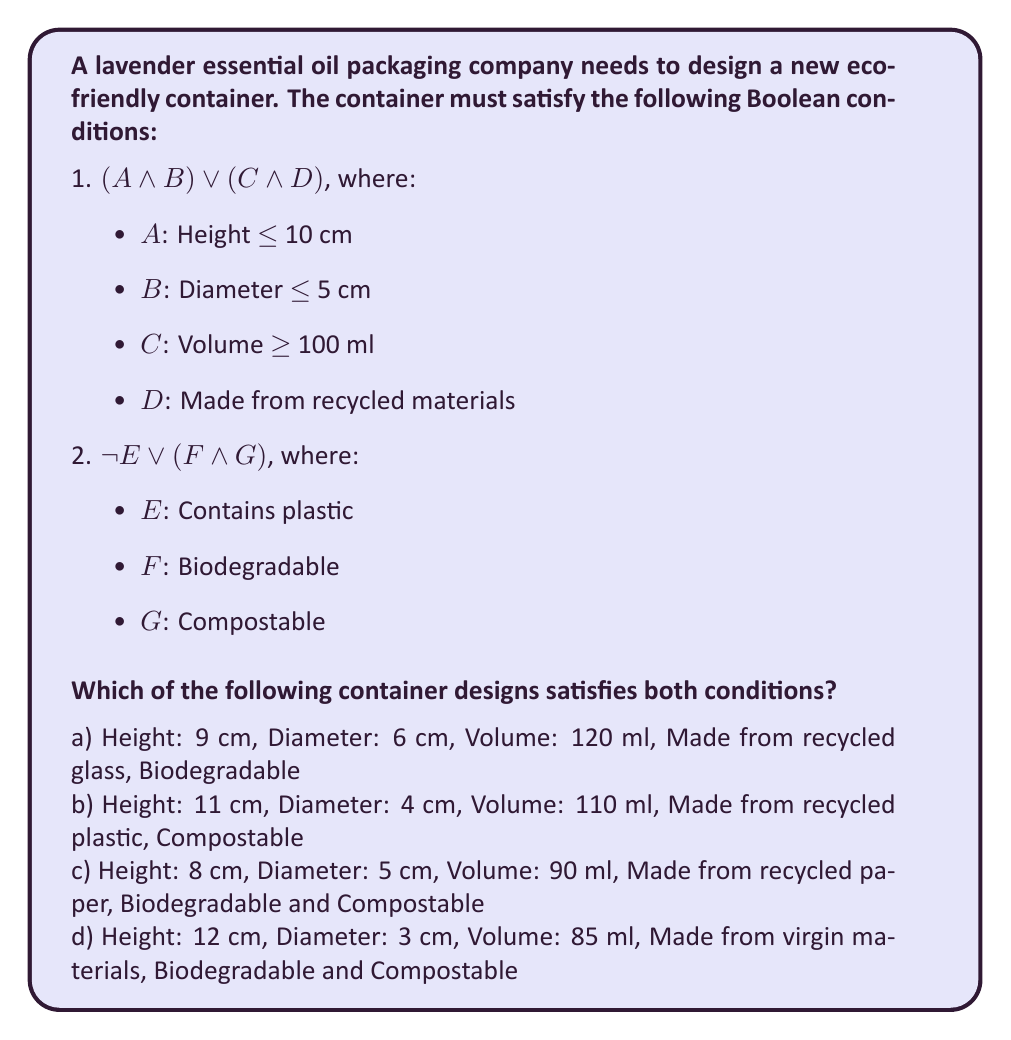Show me your answer to this math problem. Let's evaluate each option step-by-step using the given Boolean conditions:

1. Condition 1: $(A \land B) \lor (C \land D)$

2. Condition 2: $\lnot E \lor (F \land G)$

Option a:
- $A$ is true (9 cm $\leq$ 10 cm)
- $B$ is false (6 cm $\not\leq$ 5 cm)
- $C$ is true (120 ml $\geq$ 100 ml)
- $D$ is true (made from recycled glass)
- $E$ is false (glass, not plastic)
- $F$ is true (biodegradable)
- $G$ is false (not stated as compostable)

Condition 1: $(T \land F) \lor (T \land T) = F \lor T = T$
Condition 2: $\lnot F \lor (T \land F) = T \lor F = T$
Both conditions are satisfied.

Option b:
- $A$ is false (11 cm $\not\leq$ 10 cm)
- $B$ is true (4 cm $\leq$ 5 cm)
- $C$ is true (110 ml $\geq$ 100 ml)
- $D$ is true (made from recycled plastic)
- $E$ is true (contains plastic)
- $F$ is false (not stated as biodegradable)
- $G$ is true (compostable)

Condition 1: $(F \land T) \lor (T \land T) = F \lor T = T$
Condition 2: $\lnot T \lor (F \land T) = F \lor F = F$
Condition 2 is not satisfied.

Option c:
- $A$ is true (8 cm $\leq$ 10 cm)
- $B$ is true (5 cm $\leq$ 5 cm)
- $C$ is false (90 ml $\not\geq$ 100 ml)
- $D$ is true (made from recycled paper)
- $E$ is false (paper, not plastic)
- $F$ is true (biodegradable)
- $G$ is true (compostable)

Condition 1: $(T \land T) \lor (F \land T) = T \lor F = T$
Condition 2: $\lnot F \lor (T \land T) = T \lor T = T$
Both conditions are satisfied.

Option d:
- $A$ is false (12 cm $\not\leq$ 10 cm)
- $B$ is true (3 cm $\leq$ 5 cm)
- $C$ is false (85 ml $\not\geq$ 100 ml)
- $D$ is false (made from virgin materials)
- $E$ is false (not plastic)
- $F$ is true (biodegradable)
- $G$ is true (compostable)

Condition 1: $(F \land T) \lor (F \land F) = F \lor F = F$
Condition 2: $\lnot F \lor (T \land T) = T \lor T = T$
Condition 1 is not satisfied.

Therefore, options a and c satisfy both conditions.
Answer: a and c 